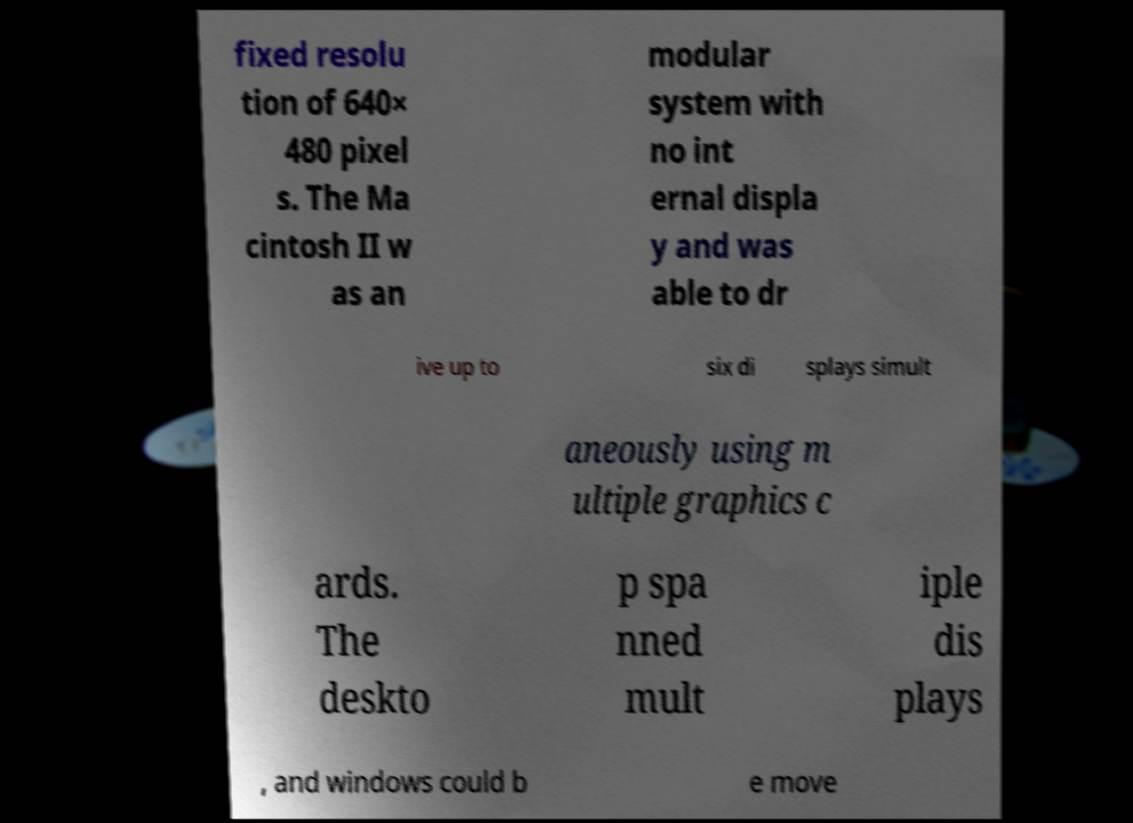I need the written content from this picture converted into text. Can you do that? fixed resolu tion of 640× 480 pixel s. The Ma cintosh II w as an modular system with no int ernal displa y and was able to dr ive up to six di splays simult aneously using m ultiple graphics c ards. The deskto p spa nned mult iple dis plays , and windows could b e move 